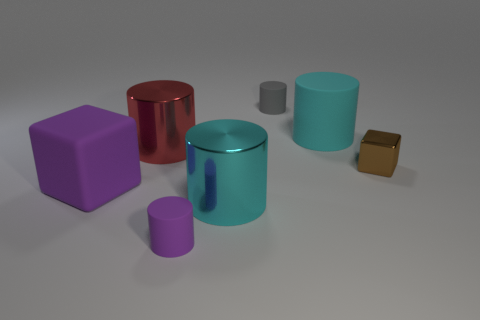There is a big cyan thing that is behind the brown thing; is its shape the same as the tiny matte thing behind the small brown shiny thing?
Make the answer very short. Yes. There is a large matte block; does it have the same color as the tiny object right of the small gray cylinder?
Ensure brevity in your answer.  No. There is a small cylinder behind the brown metal thing; is its color the same as the big rubber cylinder?
Your answer should be compact. No. What number of objects are either tiny purple rubber cylinders or cyan cylinders that are in front of the brown object?
Give a very brief answer. 2. There is a big object that is on the left side of the large cyan rubber object and behind the small block; what material is it?
Make the answer very short. Metal. There is a cyan thing that is behind the large red object; what is it made of?
Your answer should be compact. Rubber. There is another big cylinder that is the same material as the purple cylinder; what color is it?
Your response must be concise. Cyan. There is a cyan rubber object; is its shape the same as the large shiny thing behind the large purple matte thing?
Your response must be concise. Yes. There is a tiny gray matte cylinder; are there any small gray matte cylinders to the right of it?
Your answer should be very brief. No. There is another cylinder that is the same color as the big rubber cylinder; what is its material?
Offer a terse response. Metal. 